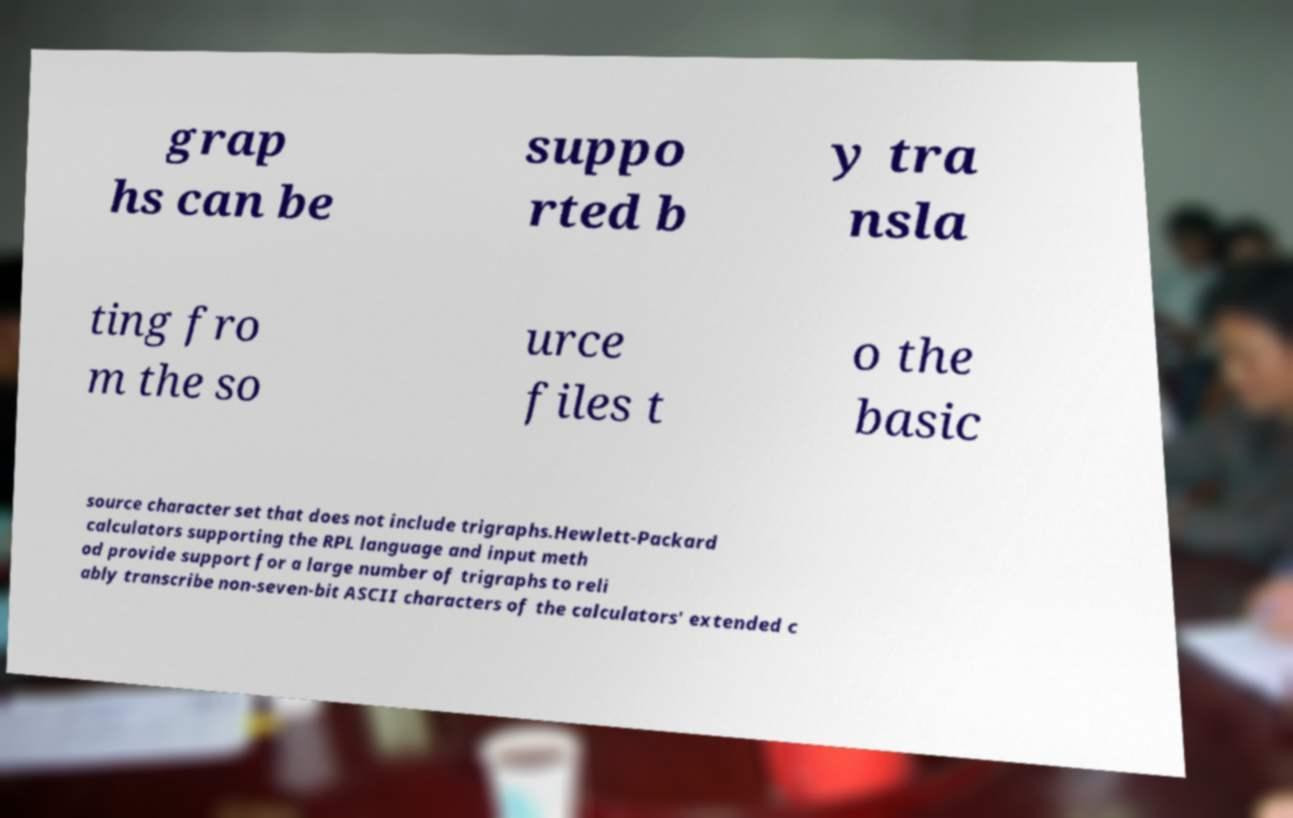Could you assist in decoding the text presented in this image and type it out clearly? grap hs can be suppo rted b y tra nsla ting fro m the so urce files t o the basic source character set that does not include trigraphs.Hewlett-Packard calculators supporting the RPL language and input meth od provide support for a large number of trigraphs to reli ably transcribe non-seven-bit ASCII characters of the calculators' extended c 